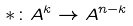Convert formula to latex. <formula><loc_0><loc_0><loc_500><loc_500>* \colon A ^ { k } \rightarrow A ^ { n - k }</formula> 